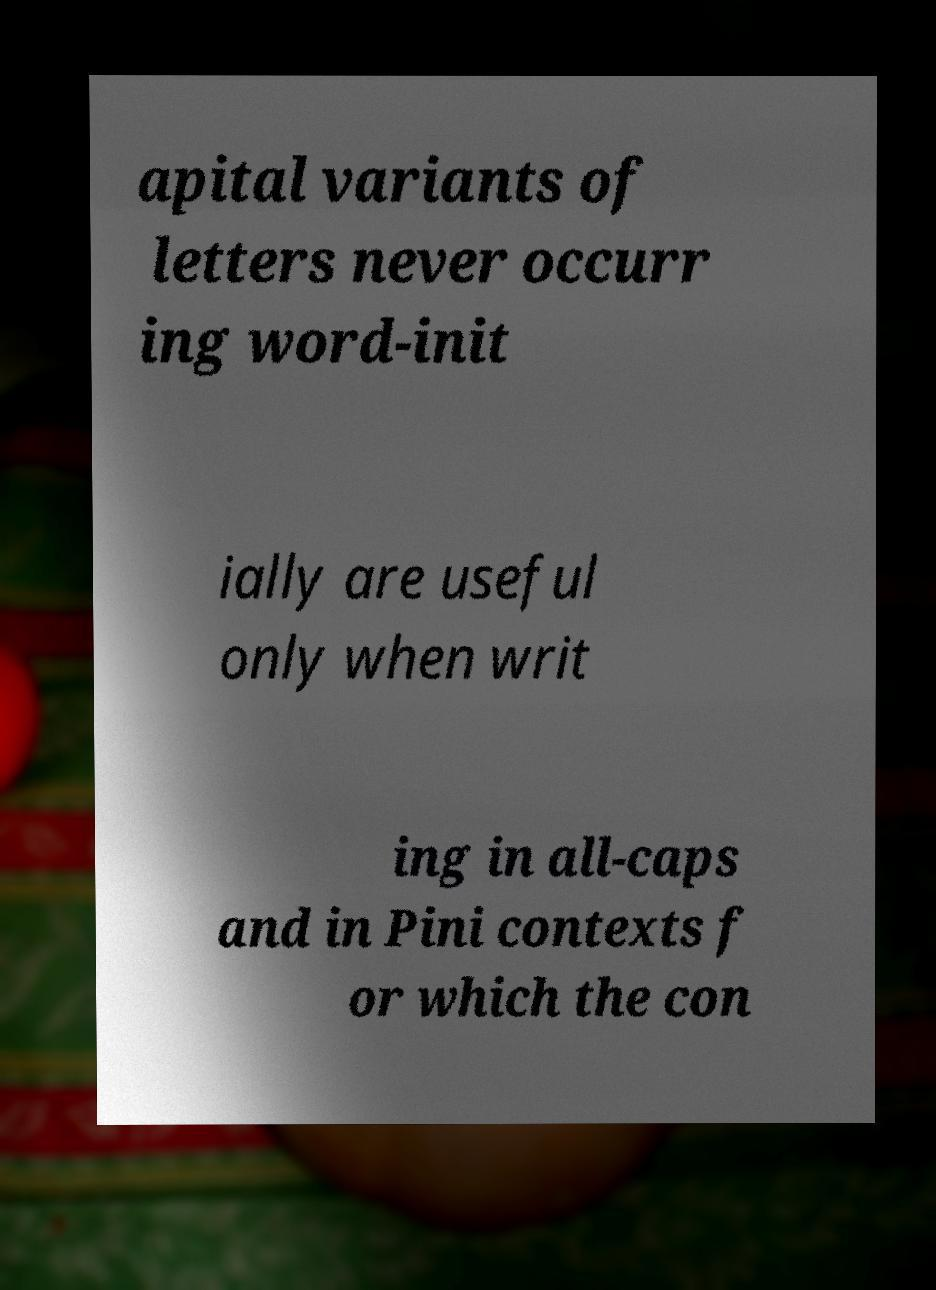For documentation purposes, I need the text within this image transcribed. Could you provide that? apital variants of letters never occurr ing word-init ially are useful only when writ ing in all-caps and in Pini contexts f or which the con 